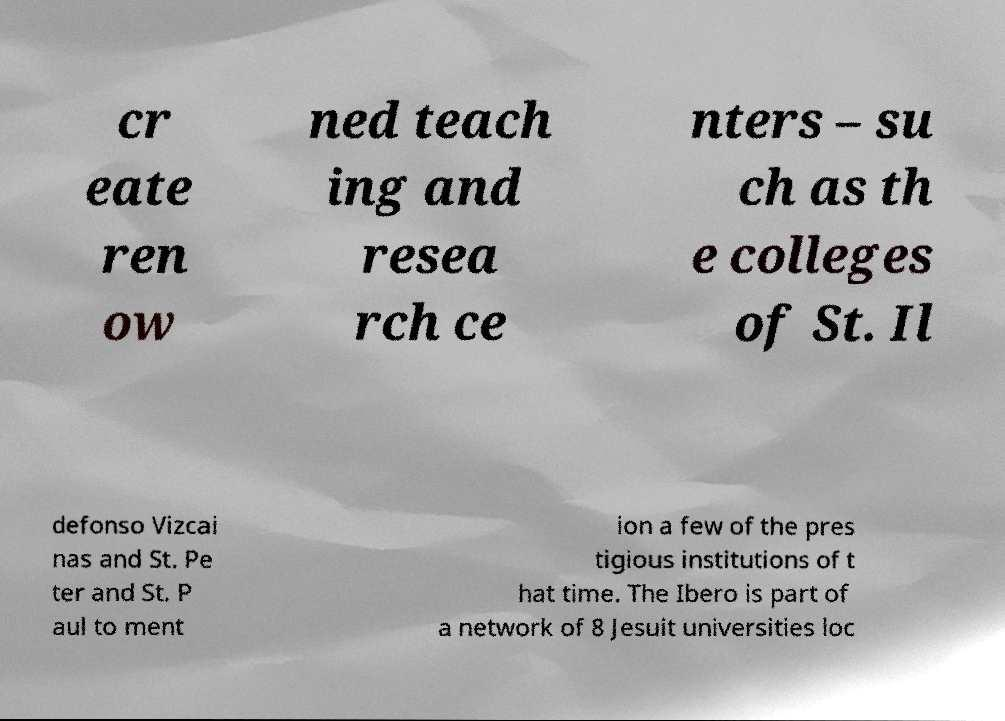What messages or text are displayed in this image? I need them in a readable, typed format. cr eate ren ow ned teach ing and resea rch ce nters – su ch as th e colleges of St. Il defonso Vizcai nas and St. Pe ter and St. P aul to ment ion a few of the pres tigious institutions of t hat time. The Ibero is part of a network of 8 Jesuit universities loc 